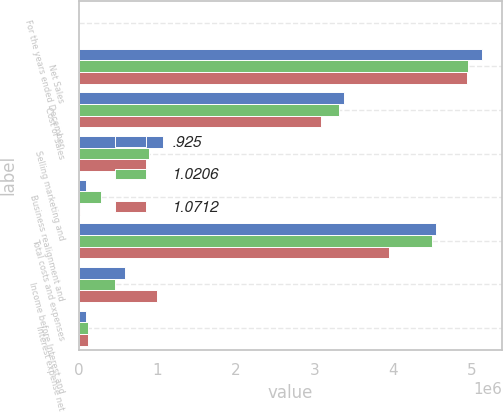Convert chart. <chart><loc_0><loc_0><loc_500><loc_500><stacked_bar_chart><ecel><fcel>For the years ended December<fcel>Net Sales<fcel>Cost of sales<fcel>Selling marketing and<fcel>Business realignment and<fcel>Total costs and expenses<fcel>Income before Interest and<fcel>Interest expense net<nl><fcel>0.925<fcel>2008<fcel>5.13277e+06<fcel>3.37505e+06<fcel>1.07302e+06<fcel>94801<fcel>4.54287e+06<fcel>589898<fcel>97876<nl><fcel>1.0206<fcel>2007<fcel>4.94672e+06<fcel>3.31515e+06<fcel>895874<fcel>276868<fcel>4.48789e+06<fcel>458827<fcel>118585<nl><fcel>1.0712<fcel>2006<fcel>4.94423e+06<fcel>3.07672e+06<fcel>860378<fcel>14576<fcel>3.95167e+06<fcel>992558<fcel>116056<nl></chart> 